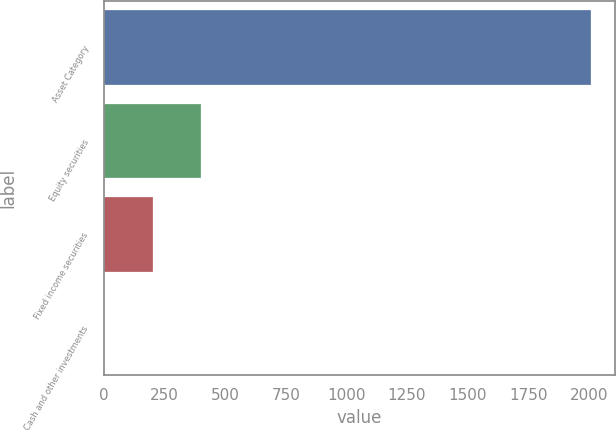Convert chart to OTSL. <chart><loc_0><loc_0><loc_500><loc_500><bar_chart><fcel>Asset Category<fcel>Equity securities<fcel>Fixed income securities<fcel>Cash and other investments<nl><fcel>2007<fcel>402.2<fcel>201.6<fcel>1<nl></chart> 